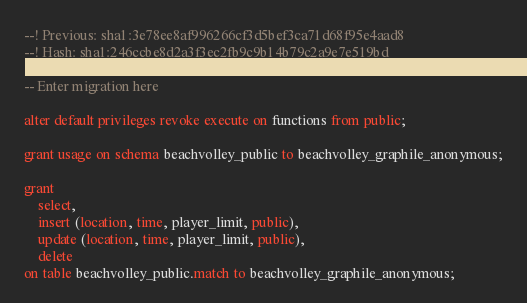Convert code to text. <code><loc_0><loc_0><loc_500><loc_500><_SQL_>--! Previous: sha1:3e78ee8af996266cf3d5bef3ca71d68f95e4aad8
--! Hash: sha1:246ccbe8d2a3f3ec2fb9c9b14b79c2a9e7e519bd

-- Enter migration here

alter default privileges revoke execute on functions from public;

grant usage on schema beachvolley_public to beachvolley_graphile_anonymous;

grant
    select,
    insert (location, time, player_limit, public),
    update (location, time, player_limit, public),
    delete
on table beachvolley_public.match to beachvolley_graphile_anonymous;
</code> 